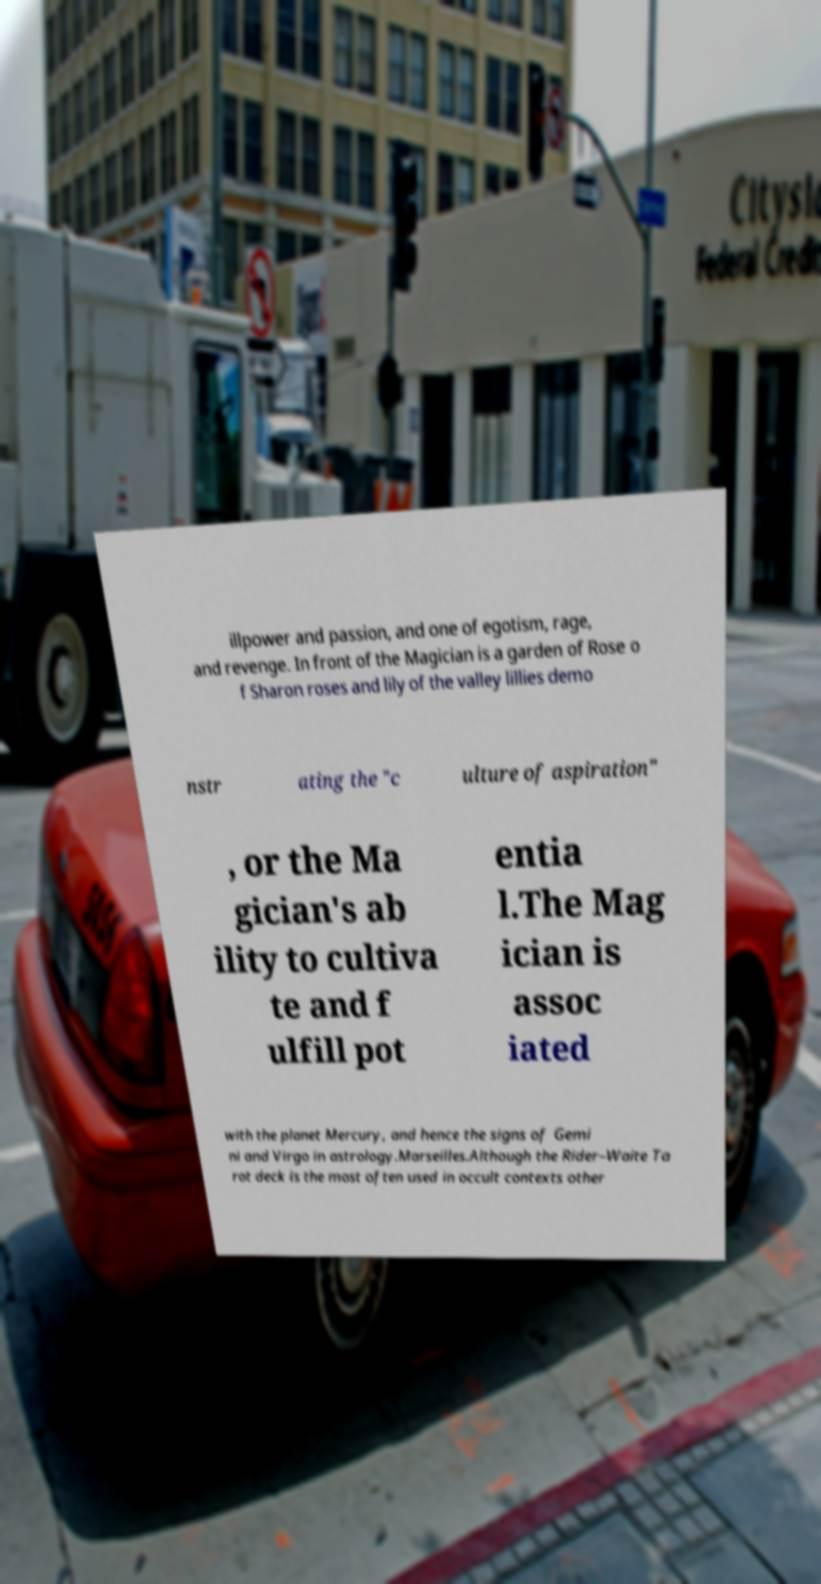Could you extract and type out the text from this image? illpower and passion, and one of egotism, rage, and revenge. In front of the Magician is a garden of Rose o f Sharon roses and lily of the valley lillies demo nstr ating the "c ulture of aspiration" , or the Ma gician's ab ility to cultiva te and f ulfill pot entia l.The Mag ician is assoc iated with the planet Mercury, and hence the signs of Gemi ni and Virgo in astrology.Marseilles.Although the Rider–Waite Ta rot deck is the most often used in occult contexts other 